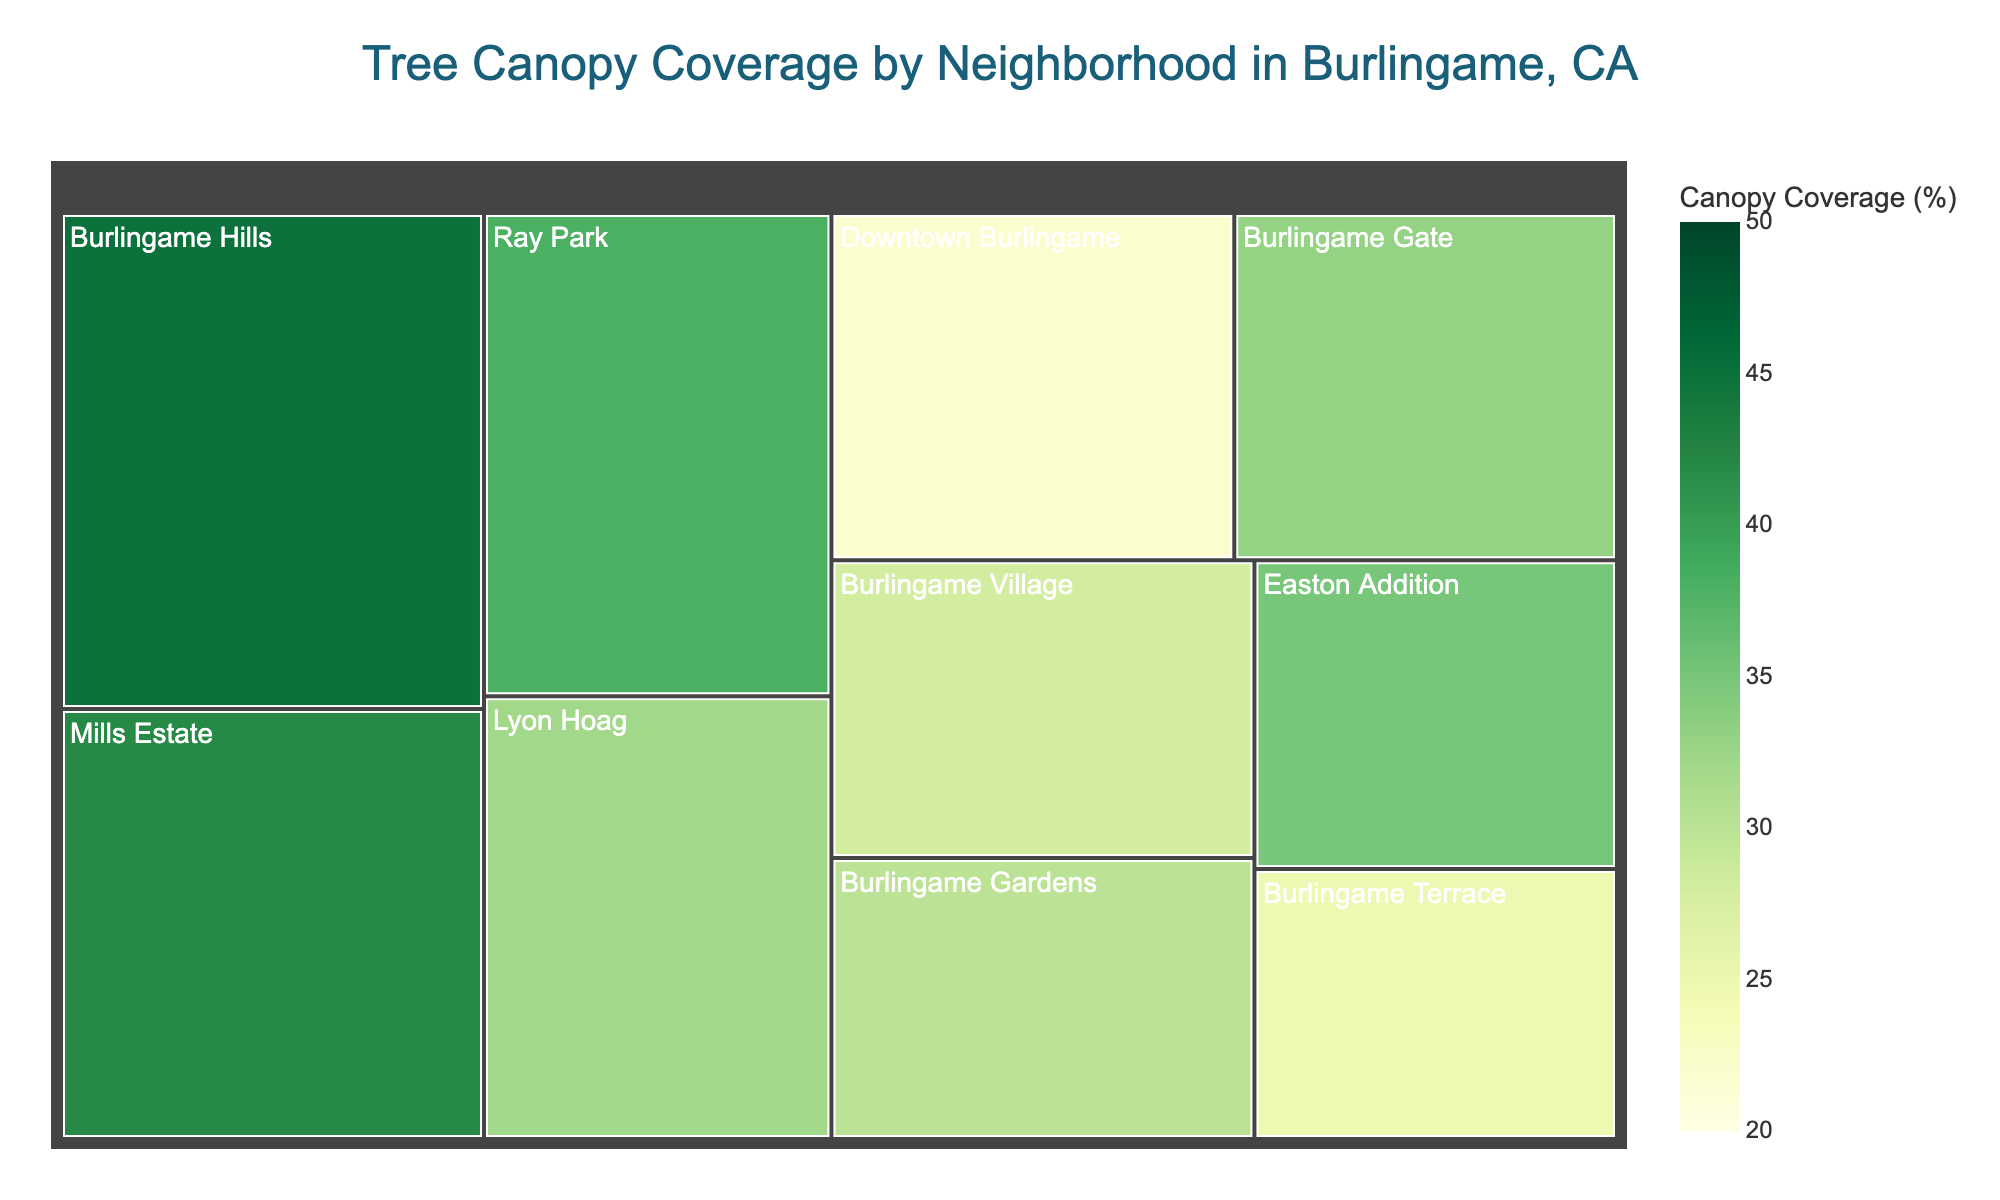What neighborhood has the highest tree canopy coverage? Look at the color intensity, the deepest green signifies the highest coverage. Burlingame Hills is the deepest green with a canopy coverage of 45%.
Answer: Burlingame Hills What is the total area of Downtown Burlingame and Ray Park combined? Identify the areas of Downtown Burlingame and Ray Park, which are 100 and 120 respectively, and sum them. 100 + 120 = 220
Answer: 220 Which neighborhood has the smallest area? Compare the area values in the treemap. Burlingame Terrace has the smallest area with 70.
Answer: Burlingame Terrace Which neighborhoods have a canopy coverage greater than 35%? Identify neighborhoods with a canopy coverage value more than 35%. These are Burlingame Hills (45%), Easton Addition (35%), Ray Park (38%), Mills Estate (42%), and Burlingame Gate (33%).
Answer: Burlingame Hills, Easton Addition, Ray Park, Mills Estate What's the average canopy coverage of Burlingame Village and Lyon Hoag? Sum the canopy coverages of Burlingame Village (28) and Lyon Hoag (32), then divide by 2. (28 + 32) / 2 = 30
Answer: 30 Which neighborhood has a higher tree canopy coverage: Burlingame Gardens or Burlingame Gate? Compare the canopy coverages: Burlingame Gardens (30%) and Burlingame Gate (33%). Burlingame Gate is higher.
Answer: Burlingame Gate How many neighborhoods have an area greater than 100? Count neighborhoods where the area value is more than 100. These are Burlingame Hills(150), Ray Park(120), Lyon Hoag(110), and Mills Estate(130). There are 4 such neighborhoods.
Answer: 4 What is the difference in canopy coverage between the neighborhoods with the highest and lowest coverages? Identify the highest (Burlingame Hills with 45%) and lowest (Downtown Burlingame with 22%) coverages, and subtract the lowest from the highest. 45 - 22 = 23
Answer: 23 What's the average area of all neighborhoods combined? Sum all area values and divide by the number of neighborhoods. (100+150+80+120+90+110+70+130+85+95) / 10 = 1030 / 10 = 103
Answer: 103 What's the total area covered in the Burlingame Gate and Burlingame Gardens? Identify and sum the areas of Burlingame Gate (95) and Burlingame Gardens (85). 95 + 85 = 180
Answer: 180 